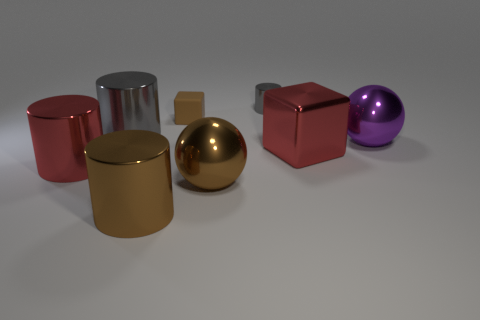Subtract all brown cylinders. How many cylinders are left? 3 Subtract all red metal cylinders. How many cylinders are left? 3 Add 2 big brown cylinders. How many objects exist? 10 Subtract 1 cylinders. How many cylinders are left? 3 Subtract all green cylinders. Subtract all purple cubes. How many cylinders are left? 4 Subtract all spheres. How many objects are left? 6 Subtract 0 purple blocks. How many objects are left? 8 Subtract all large brown metal spheres. Subtract all big purple metallic balls. How many objects are left? 6 Add 8 red metallic cylinders. How many red metallic cylinders are left? 9 Add 4 small yellow shiny things. How many small yellow shiny things exist? 4 